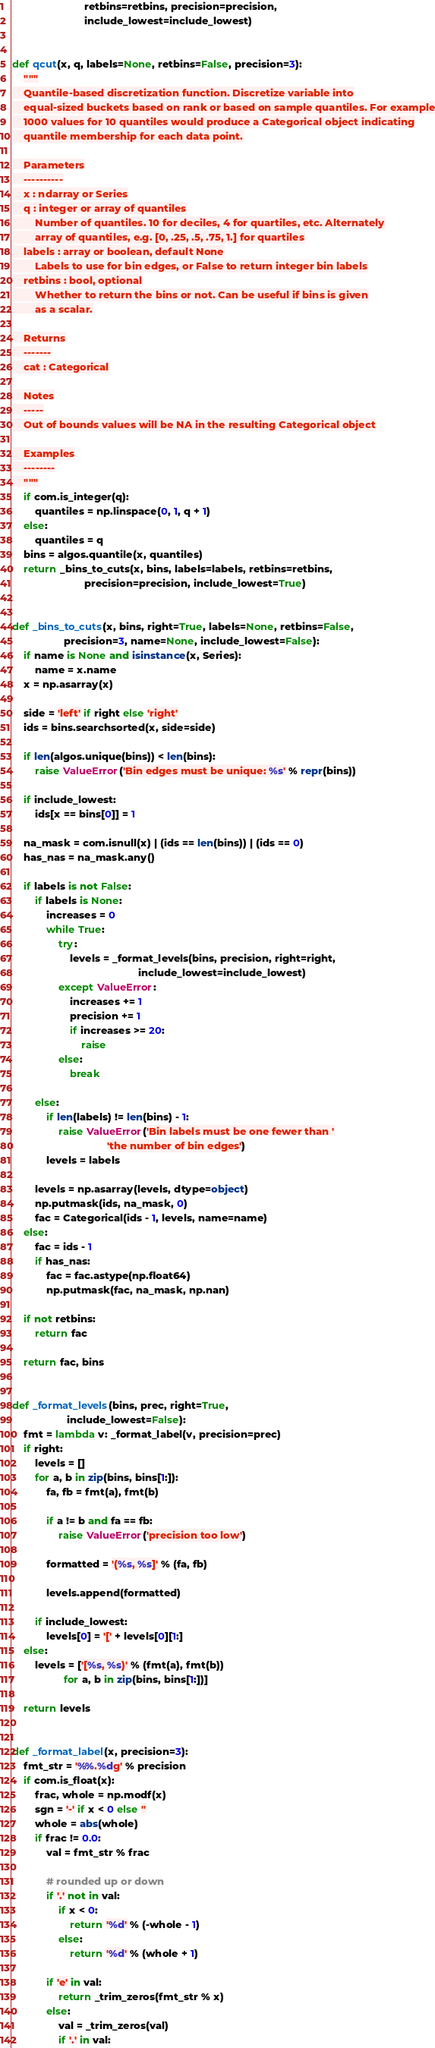<code> <loc_0><loc_0><loc_500><loc_500><_Python_>                         retbins=retbins, precision=precision,
                         include_lowest=include_lowest)


def qcut(x, q, labels=None, retbins=False, precision=3):
    """
    Quantile-based discretization function. Discretize variable into
    equal-sized buckets based on rank or based on sample quantiles. For example
    1000 values for 10 quantiles would produce a Categorical object indicating
    quantile membership for each data point.

    Parameters
    ----------
    x : ndarray or Series
    q : integer or array of quantiles
        Number of quantiles. 10 for deciles, 4 for quartiles, etc. Alternately
        array of quantiles, e.g. [0, .25, .5, .75, 1.] for quartiles
    labels : array or boolean, default None
        Labels to use for bin edges, or False to return integer bin labels
    retbins : bool, optional
        Whether to return the bins or not. Can be useful if bins is given
        as a scalar.

    Returns
    -------
    cat : Categorical

    Notes
    -----
    Out of bounds values will be NA in the resulting Categorical object

    Examples
    --------
    """
    if com.is_integer(q):
        quantiles = np.linspace(0, 1, q + 1)
    else:
        quantiles = q
    bins = algos.quantile(x, quantiles)
    return _bins_to_cuts(x, bins, labels=labels, retbins=retbins,
                         precision=precision, include_lowest=True)


def _bins_to_cuts(x, bins, right=True, labels=None, retbins=False,
                  precision=3, name=None, include_lowest=False):
    if name is None and isinstance(x, Series):
        name = x.name
    x = np.asarray(x)

    side = 'left' if right else 'right'
    ids = bins.searchsorted(x, side=side)

    if len(algos.unique(bins)) < len(bins):
        raise ValueError('Bin edges must be unique: %s' % repr(bins))

    if include_lowest:
        ids[x == bins[0]] = 1

    na_mask = com.isnull(x) | (ids == len(bins)) | (ids == 0)
    has_nas = na_mask.any()

    if labels is not False:
        if labels is None:
            increases = 0
            while True:
                try:
                    levels = _format_levels(bins, precision, right=right,
                                            include_lowest=include_lowest)
                except ValueError:
                    increases += 1
                    precision += 1
                    if increases >= 20:
                        raise
                else:
                    break

        else:
            if len(labels) != len(bins) - 1:
                raise ValueError('Bin labels must be one fewer than '
                                 'the number of bin edges')
            levels = labels

        levels = np.asarray(levels, dtype=object)
        np.putmask(ids, na_mask, 0)
        fac = Categorical(ids - 1, levels, name=name)
    else:
        fac = ids - 1
        if has_nas:
            fac = fac.astype(np.float64)
            np.putmask(fac, na_mask, np.nan)

    if not retbins:
        return fac

    return fac, bins


def _format_levels(bins, prec, right=True,
                   include_lowest=False):
    fmt = lambda v: _format_label(v, precision=prec)
    if right:
        levels = []
        for a, b in zip(bins, bins[1:]):
            fa, fb = fmt(a), fmt(b)

            if a != b and fa == fb:
                raise ValueError('precision too low')

            formatted = '(%s, %s]' % (fa, fb)

            levels.append(formatted)

        if include_lowest:
            levels[0] = '[' + levels[0][1:]
    else:
        levels = ['[%s, %s)' % (fmt(a), fmt(b))
                  for a, b in zip(bins, bins[1:])]

    return levels


def _format_label(x, precision=3):
    fmt_str = '%%.%dg' % precision
    if com.is_float(x):
        frac, whole = np.modf(x)
        sgn = '-' if x < 0 else ''
        whole = abs(whole)
        if frac != 0.0:
            val = fmt_str % frac

            # rounded up or down
            if '.' not in val:
                if x < 0:
                    return '%d' % (-whole - 1)
                else:
                    return '%d' % (whole + 1)

            if 'e' in val:
                return _trim_zeros(fmt_str % x)
            else:
                val = _trim_zeros(val)
                if '.' in val:</code> 